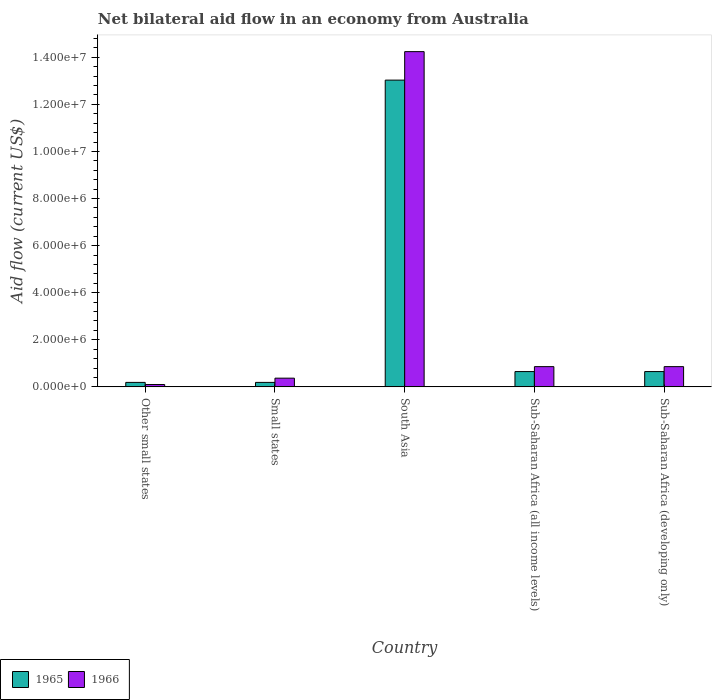How many different coloured bars are there?
Give a very brief answer. 2. What is the label of the 1st group of bars from the left?
Your answer should be compact. Other small states. What is the net bilateral aid flow in 1965 in Sub-Saharan Africa (all income levels)?
Your response must be concise. 6.50e+05. Across all countries, what is the maximum net bilateral aid flow in 1966?
Your answer should be very brief. 1.42e+07. In which country was the net bilateral aid flow in 1965 maximum?
Offer a very short reply. South Asia. In which country was the net bilateral aid flow in 1965 minimum?
Ensure brevity in your answer.  Other small states. What is the total net bilateral aid flow in 1966 in the graph?
Provide a short and direct response. 1.64e+07. What is the difference between the net bilateral aid flow in 1965 in Small states and that in Sub-Saharan Africa (all income levels)?
Keep it short and to the point. -4.60e+05. What is the difference between the net bilateral aid flow in 1966 in Small states and the net bilateral aid flow in 1965 in Sub-Saharan Africa (all income levels)?
Give a very brief answer. -2.80e+05. What is the average net bilateral aid flow in 1965 per country?
Give a very brief answer. 2.94e+06. In how many countries, is the net bilateral aid flow in 1966 greater than 1200000 US$?
Keep it short and to the point. 1. Is the net bilateral aid flow in 1965 in Small states less than that in South Asia?
Your answer should be very brief. Yes. Is the difference between the net bilateral aid flow in 1965 in Small states and Sub-Saharan Africa (all income levels) greater than the difference between the net bilateral aid flow in 1966 in Small states and Sub-Saharan Africa (all income levels)?
Make the answer very short. Yes. What is the difference between the highest and the second highest net bilateral aid flow in 1965?
Your answer should be compact. 1.24e+07. What is the difference between the highest and the lowest net bilateral aid flow in 1966?
Provide a short and direct response. 1.41e+07. In how many countries, is the net bilateral aid flow in 1966 greater than the average net bilateral aid flow in 1966 taken over all countries?
Your answer should be compact. 1. Is the sum of the net bilateral aid flow in 1965 in Small states and South Asia greater than the maximum net bilateral aid flow in 1966 across all countries?
Make the answer very short. No. What does the 2nd bar from the left in Sub-Saharan Africa (developing only) represents?
Offer a terse response. 1966. What does the 1st bar from the right in Other small states represents?
Keep it short and to the point. 1966. Are all the bars in the graph horizontal?
Offer a very short reply. No. What is the difference between two consecutive major ticks on the Y-axis?
Your answer should be very brief. 2.00e+06. Does the graph contain any zero values?
Offer a terse response. No. How many legend labels are there?
Offer a terse response. 2. What is the title of the graph?
Make the answer very short. Net bilateral aid flow in an economy from Australia. Does "1985" appear as one of the legend labels in the graph?
Ensure brevity in your answer.  No. What is the label or title of the X-axis?
Your response must be concise. Country. What is the label or title of the Y-axis?
Your response must be concise. Aid flow (current US$). What is the Aid flow (current US$) in 1965 in Other small states?
Provide a succinct answer. 1.90e+05. What is the Aid flow (current US$) in 1965 in Small states?
Your answer should be compact. 1.90e+05. What is the Aid flow (current US$) of 1965 in South Asia?
Your answer should be compact. 1.30e+07. What is the Aid flow (current US$) in 1966 in South Asia?
Provide a short and direct response. 1.42e+07. What is the Aid flow (current US$) of 1965 in Sub-Saharan Africa (all income levels)?
Your response must be concise. 6.50e+05. What is the Aid flow (current US$) in 1966 in Sub-Saharan Africa (all income levels)?
Give a very brief answer. 8.60e+05. What is the Aid flow (current US$) in 1965 in Sub-Saharan Africa (developing only)?
Offer a very short reply. 6.50e+05. What is the Aid flow (current US$) of 1966 in Sub-Saharan Africa (developing only)?
Give a very brief answer. 8.60e+05. Across all countries, what is the maximum Aid flow (current US$) of 1965?
Make the answer very short. 1.30e+07. Across all countries, what is the maximum Aid flow (current US$) of 1966?
Ensure brevity in your answer.  1.42e+07. Across all countries, what is the minimum Aid flow (current US$) of 1966?
Offer a very short reply. 1.00e+05. What is the total Aid flow (current US$) of 1965 in the graph?
Offer a terse response. 1.47e+07. What is the total Aid flow (current US$) of 1966 in the graph?
Give a very brief answer. 1.64e+07. What is the difference between the Aid flow (current US$) in 1966 in Other small states and that in Small states?
Offer a very short reply. -2.70e+05. What is the difference between the Aid flow (current US$) in 1965 in Other small states and that in South Asia?
Provide a succinct answer. -1.28e+07. What is the difference between the Aid flow (current US$) of 1966 in Other small states and that in South Asia?
Provide a succinct answer. -1.41e+07. What is the difference between the Aid flow (current US$) in 1965 in Other small states and that in Sub-Saharan Africa (all income levels)?
Ensure brevity in your answer.  -4.60e+05. What is the difference between the Aid flow (current US$) in 1966 in Other small states and that in Sub-Saharan Africa (all income levels)?
Your answer should be very brief. -7.60e+05. What is the difference between the Aid flow (current US$) in 1965 in Other small states and that in Sub-Saharan Africa (developing only)?
Provide a short and direct response. -4.60e+05. What is the difference between the Aid flow (current US$) of 1966 in Other small states and that in Sub-Saharan Africa (developing only)?
Keep it short and to the point. -7.60e+05. What is the difference between the Aid flow (current US$) of 1965 in Small states and that in South Asia?
Offer a terse response. -1.28e+07. What is the difference between the Aid flow (current US$) of 1966 in Small states and that in South Asia?
Give a very brief answer. -1.39e+07. What is the difference between the Aid flow (current US$) in 1965 in Small states and that in Sub-Saharan Africa (all income levels)?
Keep it short and to the point. -4.60e+05. What is the difference between the Aid flow (current US$) of 1966 in Small states and that in Sub-Saharan Africa (all income levels)?
Your answer should be compact. -4.90e+05. What is the difference between the Aid flow (current US$) of 1965 in Small states and that in Sub-Saharan Africa (developing only)?
Provide a succinct answer. -4.60e+05. What is the difference between the Aid flow (current US$) of 1966 in Small states and that in Sub-Saharan Africa (developing only)?
Provide a succinct answer. -4.90e+05. What is the difference between the Aid flow (current US$) of 1965 in South Asia and that in Sub-Saharan Africa (all income levels)?
Ensure brevity in your answer.  1.24e+07. What is the difference between the Aid flow (current US$) in 1966 in South Asia and that in Sub-Saharan Africa (all income levels)?
Your response must be concise. 1.34e+07. What is the difference between the Aid flow (current US$) in 1965 in South Asia and that in Sub-Saharan Africa (developing only)?
Keep it short and to the point. 1.24e+07. What is the difference between the Aid flow (current US$) of 1966 in South Asia and that in Sub-Saharan Africa (developing only)?
Offer a terse response. 1.34e+07. What is the difference between the Aid flow (current US$) in 1965 in Other small states and the Aid flow (current US$) in 1966 in South Asia?
Ensure brevity in your answer.  -1.40e+07. What is the difference between the Aid flow (current US$) in 1965 in Other small states and the Aid flow (current US$) in 1966 in Sub-Saharan Africa (all income levels)?
Offer a very short reply. -6.70e+05. What is the difference between the Aid flow (current US$) in 1965 in Other small states and the Aid flow (current US$) in 1966 in Sub-Saharan Africa (developing only)?
Ensure brevity in your answer.  -6.70e+05. What is the difference between the Aid flow (current US$) in 1965 in Small states and the Aid flow (current US$) in 1966 in South Asia?
Provide a succinct answer. -1.40e+07. What is the difference between the Aid flow (current US$) of 1965 in Small states and the Aid flow (current US$) of 1966 in Sub-Saharan Africa (all income levels)?
Keep it short and to the point. -6.70e+05. What is the difference between the Aid flow (current US$) of 1965 in Small states and the Aid flow (current US$) of 1966 in Sub-Saharan Africa (developing only)?
Your answer should be compact. -6.70e+05. What is the difference between the Aid flow (current US$) of 1965 in South Asia and the Aid flow (current US$) of 1966 in Sub-Saharan Africa (all income levels)?
Your answer should be compact. 1.22e+07. What is the difference between the Aid flow (current US$) of 1965 in South Asia and the Aid flow (current US$) of 1966 in Sub-Saharan Africa (developing only)?
Keep it short and to the point. 1.22e+07. What is the average Aid flow (current US$) of 1965 per country?
Give a very brief answer. 2.94e+06. What is the average Aid flow (current US$) in 1966 per country?
Provide a succinct answer. 3.29e+06. What is the difference between the Aid flow (current US$) in 1965 and Aid flow (current US$) in 1966 in Small states?
Ensure brevity in your answer.  -1.80e+05. What is the difference between the Aid flow (current US$) of 1965 and Aid flow (current US$) of 1966 in South Asia?
Ensure brevity in your answer.  -1.21e+06. What is the difference between the Aid flow (current US$) of 1965 and Aid flow (current US$) of 1966 in Sub-Saharan Africa (all income levels)?
Your answer should be compact. -2.10e+05. What is the difference between the Aid flow (current US$) of 1965 and Aid flow (current US$) of 1966 in Sub-Saharan Africa (developing only)?
Your answer should be very brief. -2.10e+05. What is the ratio of the Aid flow (current US$) in 1966 in Other small states to that in Small states?
Your response must be concise. 0.27. What is the ratio of the Aid flow (current US$) of 1965 in Other small states to that in South Asia?
Provide a succinct answer. 0.01. What is the ratio of the Aid flow (current US$) of 1966 in Other small states to that in South Asia?
Offer a very short reply. 0.01. What is the ratio of the Aid flow (current US$) of 1965 in Other small states to that in Sub-Saharan Africa (all income levels)?
Your response must be concise. 0.29. What is the ratio of the Aid flow (current US$) of 1966 in Other small states to that in Sub-Saharan Africa (all income levels)?
Ensure brevity in your answer.  0.12. What is the ratio of the Aid flow (current US$) of 1965 in Other small states to that in Sub-Saharan Africa (developing only)?
Provide a short and direct response. 0.29. What is the ratio of the Aid flow (current US$) in 1966 in Other small states to that in Sub-Saharan Africa (developing only)?
Give a very brief answer. 0.12. What is the ratio of the Aid flow (current US$) in 1965 in Small states to that in South Asia?
Keep it short and to the point. 0.01. What is the ratio of the Aid flow (current US$) of 1966 in Small states to that in South Asia?
Your answer should be very brief. 0.03. What is the ratio of the Aid flow (current US$) in 1965 in Small states to that in Sub-Saharan Africa (all income levels)?
Keep it short and to the point. 0.29. What is the ratio of the Aid flow (current US$) of 1966 in Small states to that in Sub-Saharan Africa (all income levels)?
Provide a short and direct response. 0.43. What is the ratio of the Aid flow (current US$) in 1965 in Small states to that in Sub-Saharan Africa (developing only)?
Keep it short and to the point. 0.29. What is the ratio of the Aid flow (current US$) in 1966 in Small states to that in Sub-Saharan Africa (developing only)?
Keep it short and to the point. 0.43. What is the ratio of the Aid flow (current US$) in 1965 in South Asia to that in Sub-Saharan Africa (all income levels)?
Offer a very short reply. 20.05. What is the ratio of the Aid flow (current US$) in 1966 in South Asia to that in Sub-Saharan Africa (all income levels)?
Ensure brevity in your answer.  16.56. What is the ratio of the Aid flow (current US$) in 1965 in South Asia to that in Sub-Saharan Africa (developing only)?
Your response must be concise. 20.05. What is the ratio of the Aid flow (current US$) in 1966 in South Asia to that in Sub-Saharan Africa (developing only)?
Provide a succinct answer. 16.56. What is the difference between the highest and the second highest Aid flow (current US$) of 1965?
Ensure brevity in your answer.  1.24e+07. What is the difference between the highest and the second highest Aid flow (current US$) of 1966?
Make the answer very short. 1.34e+07. What is the difference between the highest and the lowest Aid flow (current US$) of 1965?
Offer a terse response. 1.28e+07. What is the difference between the highest and the lowest Aid flow (current US$) of 1966?
Provide a short and direct response. 1.41e+07. 